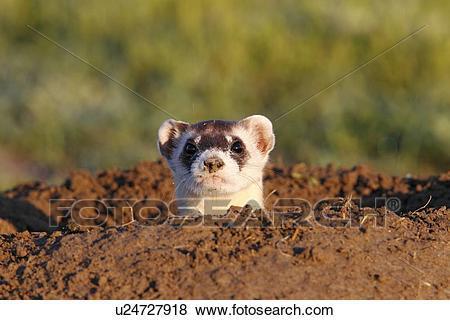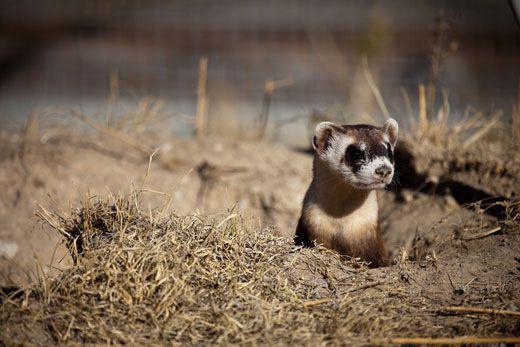The first image is the image on the left, the second image is the image on the right. Assess this claim about the two images: "Each image shows exactly one ferret emerging from a hole in the ground.". Correct or not? Answer yes or no. Yes. 